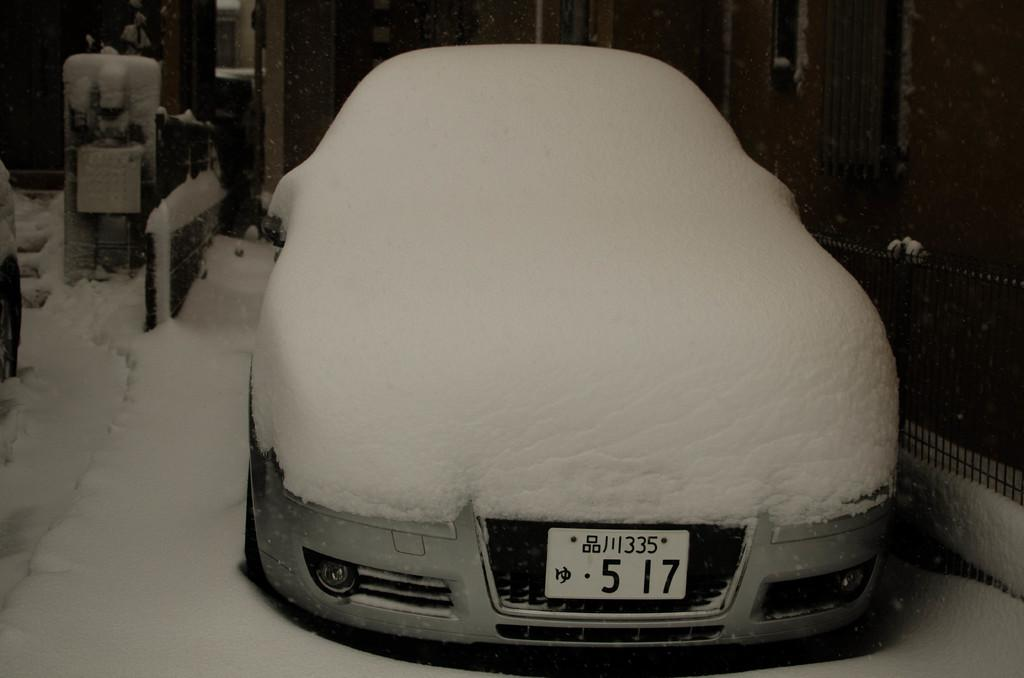<image>
Summarize the visual content of the image. Snow covers a silver car with the license plate 5 17. 